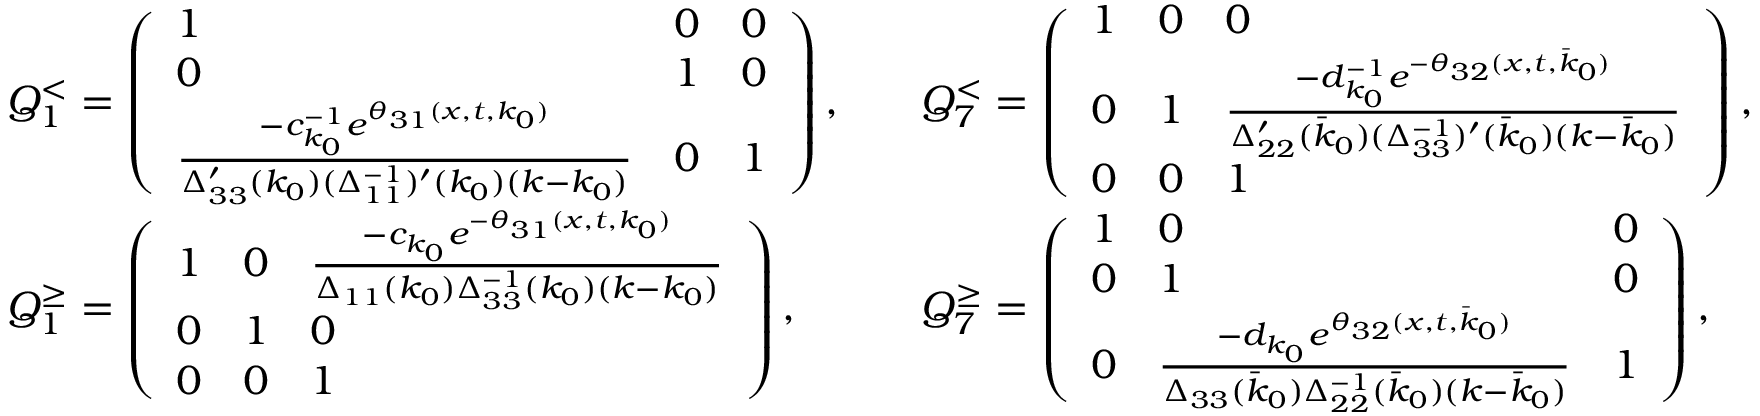<formula> <loc_0><loc_0><loc_500><loc_500>\begin{array} { r l r l } & { Q _ { 1 } ^ { < } = \left ( \begin{array} { l l l } { 1 } & { 0 } & { 0 } \\ { 0 } & { 1 } & { 0 } \\ { \frac { - c _ { k _ { 0 } } ^ { - 1 } e ^ { \theta _ { 3 1 } ( x , t , k _ { 0 } ) } } { \Delta _ { 3 3 } ^ { \prime } ( k _ { 0 } ) ( \Delta _ { 1 1 } ^ { - 1 } ) ^ { \prime } ( k _ { 0 } ) ( k - k _ { 0 } ) } } & { 0 } & { 1 } \end{array} \right ) , } & & { Q _ { 7 } ^ { < } = \left ( \begin{array} { l l l } { 1 } & { 0 } & { 0 } \\ { 0 } & { 1 } & { \frac { - d _ { k _ { 0 } } ^ { - 1 } e ^ { - \theta _ { 3 2 } ( x , t , \bar { k } _ { 0 } ) } } { \Delta _ { 2 2 } ^ { \prime } ( \bar { k } _ { 0 } ) ( \Delta _ { 3 3 } ^ { - 1 } ) ^ { \prime } ( \bar { k } _ { 0 } ) ( k - \bar { k } _ { 0 } ) } } \\ { 0 } & { 0 } & { 1 } \end{array} \right ) , } \\ & { Q _ { 1 } ^ { \geq } = \left ( \begin{array} { l l l } { 1 } & { 0 } & { \frac { - c _ { k _ { 0 } } e ^ { - \theta _ { 3 1 } ( x , t , k _ { 0 } ) } } { \Delta _ { 1 1 } ( k _ { 0 } ) \Delta _ { 3 3 } ^ { - 1 } ( k _ { 0 } ) ( k - k _ { 0 } ) } } \\ { 0 } & { 1 } & { 0 } \\ { 0 } & { 0 } & { 1 } \end{array} \right ) , } & & { Q _ { 7 } ^ { \geq } = \left ( \begin{array} { l l l } { 1 } & { 0 } & { 0 } \\ { 0 } & { 1 } & { 0 } \\ { 0 } & { \frac { - d _ { k _ { 0 } } e ^ { \theta _ { 3 2 } ( x , t , \bar { k } _ { 0 } ) } } { \Delta _ { 3 3 } ( \bar { k } _ { 0 } ) \Delta _ { 2 2 } ^ { - 1 } ( \bar { k } _ { 0 } ) ( k - \bar { k } _ { 0 } ) } } & { 1 } \end{array} \right ) , } \end{array}</formula> 